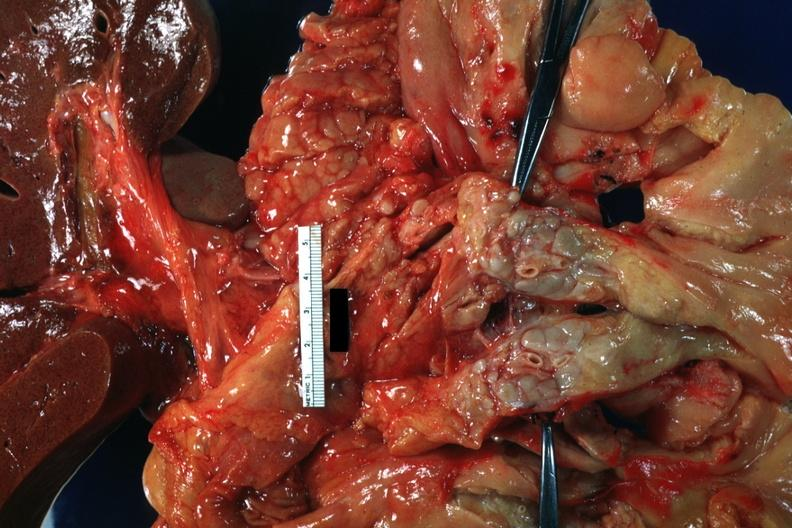what is present?
Answer the question using a single word or phrase. Lymph node 